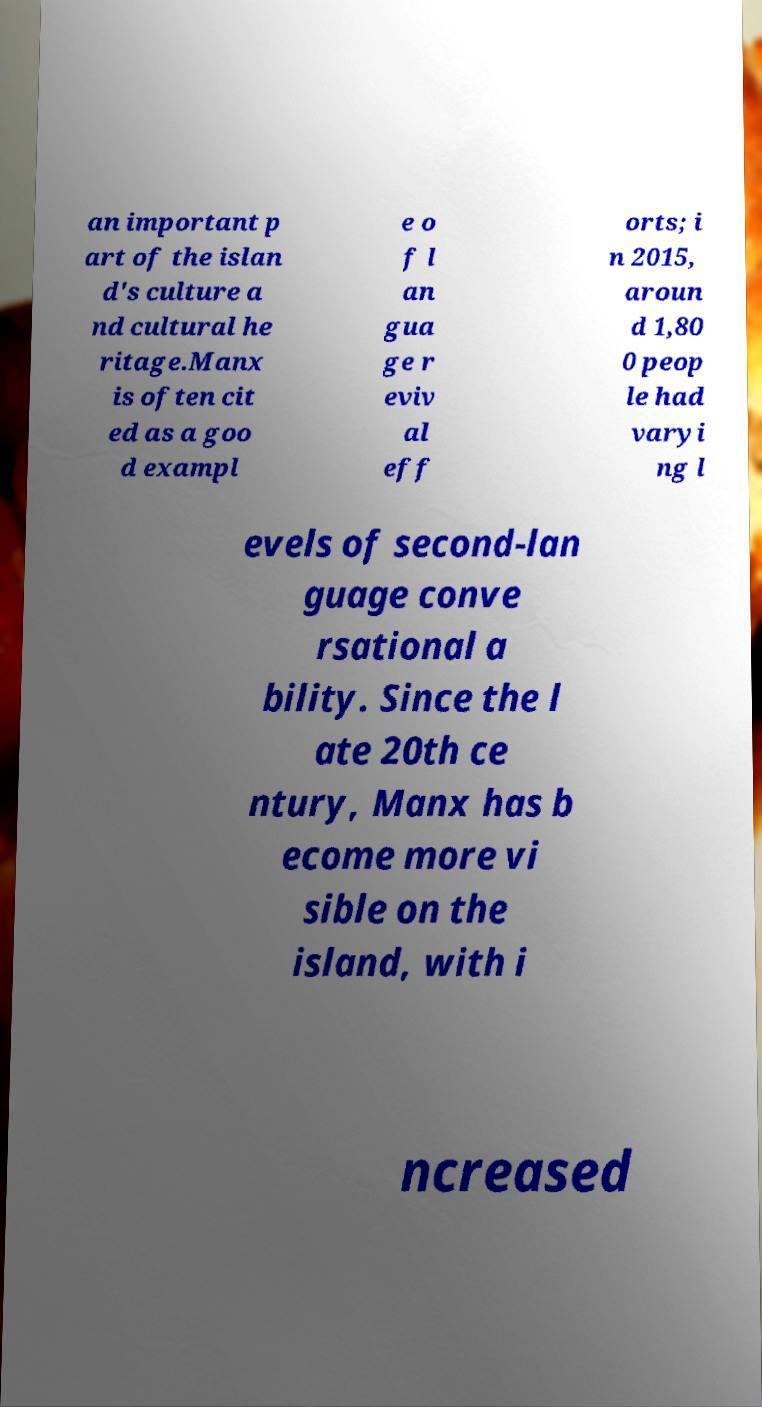There's text embedded in this image that I need extracted. Can you transcribe it verbatim? an important p art of the islan d's culture a nd cultural he ritage.Manx is often cit ed as a goo d exampl e o f l an gua ge r eviv al eff orts; i n 2015, aroun d 1,80 0 peop le had varyi ng l evels of second-lan guage conve rsational a bility. Since the l ate 20th ce ntury, Manx has b ecome more vi sible on the island, with i ncreased 